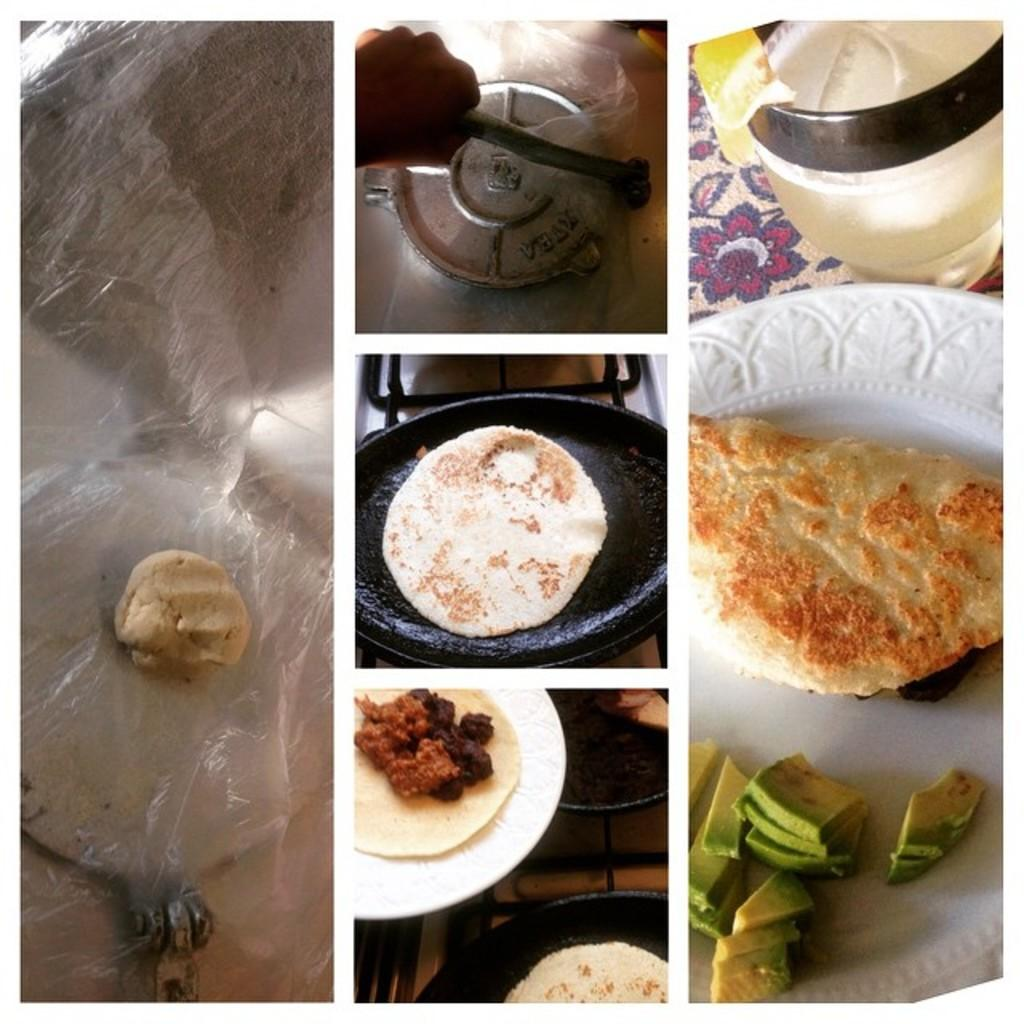What type of artwork is the image? The image is a collage. What can be seen on the plates in the image? There are food items on the plates in the image. What cooking utensil is present in the image? There is a pan in the image. What is the person's hand doing in the image? The person's hand is pressing a chapati maker. What type of beverage is in the glass in the image? There is a glass with juice in it. Can you see a stove in the image? There is no stove present in the image. Is there a snake visible in the image? There is no snake present in the image. 